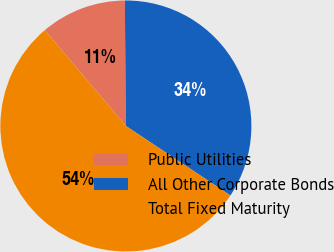Convert chart to OTSL. <chart><loc_0><loc_0><loc_500><loc_500><pie_chart><fcel>Public Utilities<fcel>All Other Corporate Bonds<fcel>Total Fixed Maturity<nl><fcel>11.04%<fcel>34.47%<fcel>54.49%<nl></chart> 